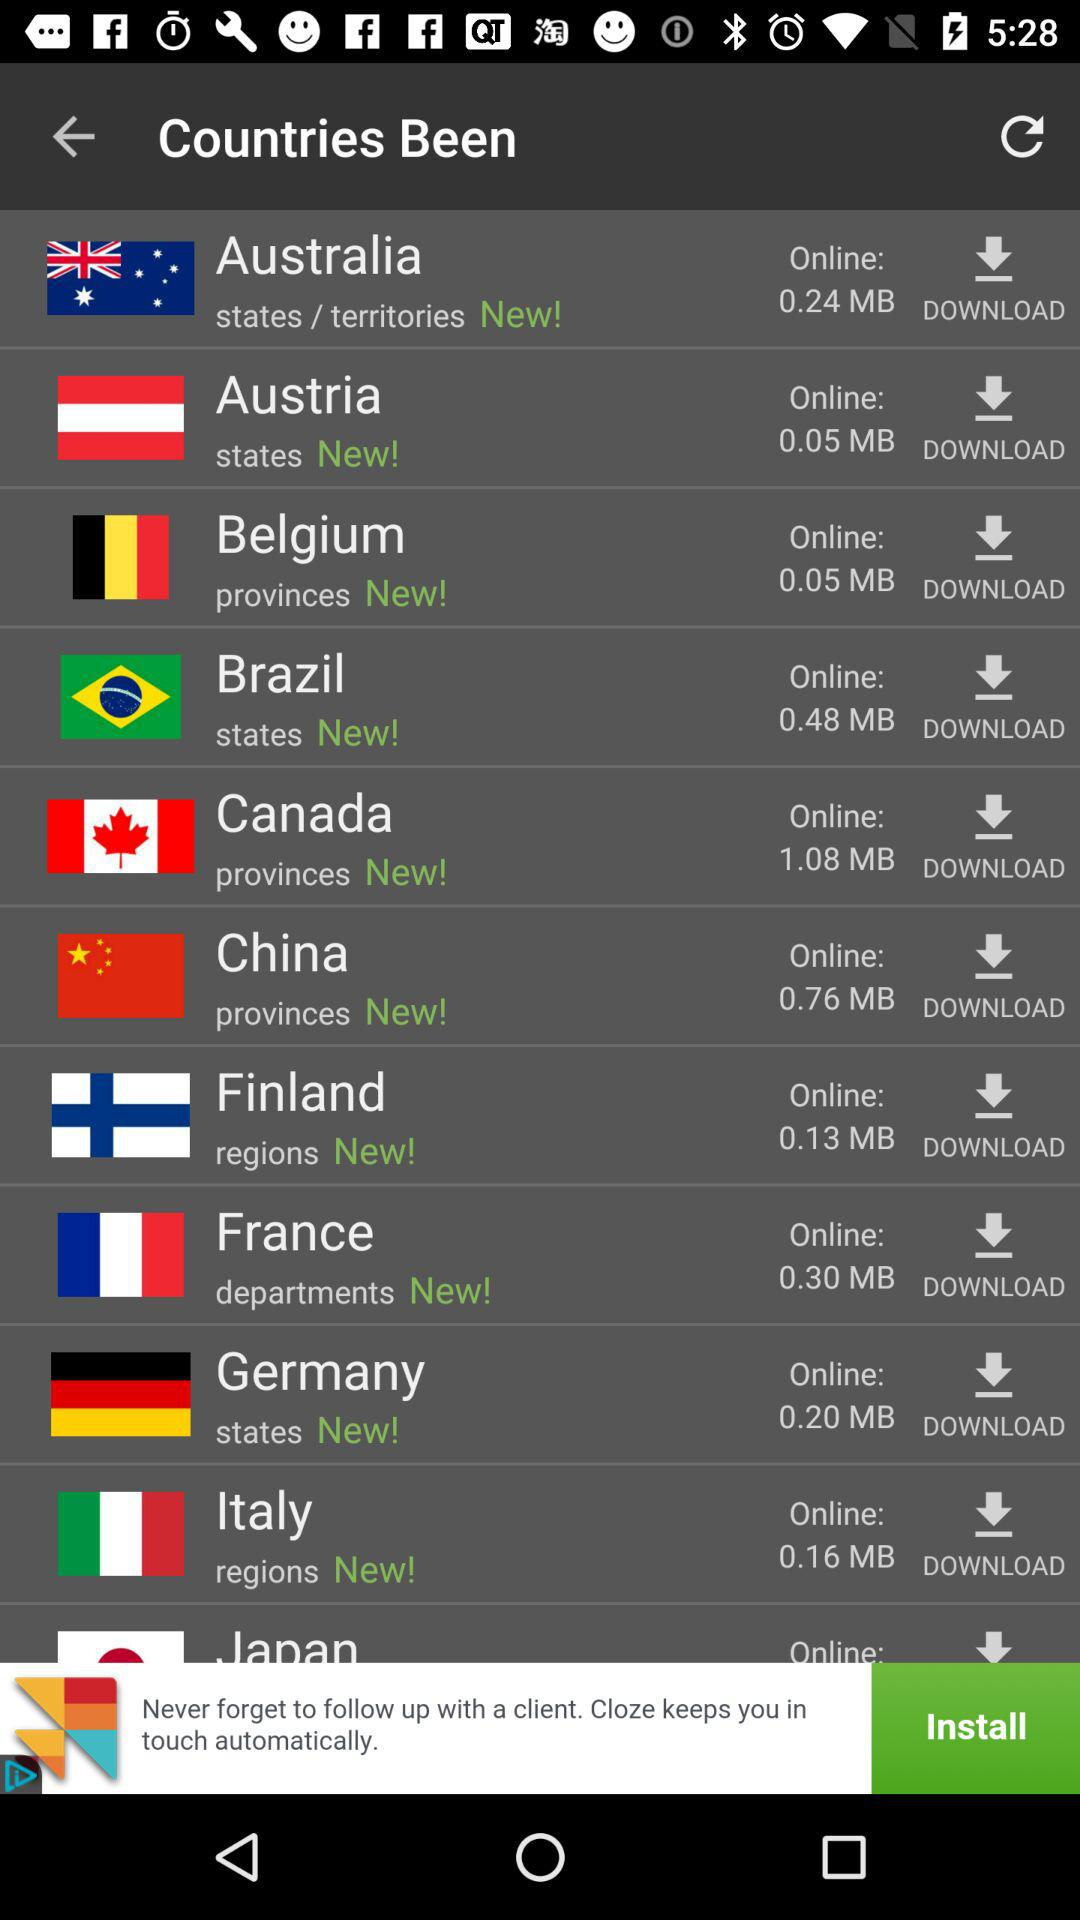For which country has the size of 0.16 MB been mentioned? The size of 0.16 MB has been mentioned for Italy. 